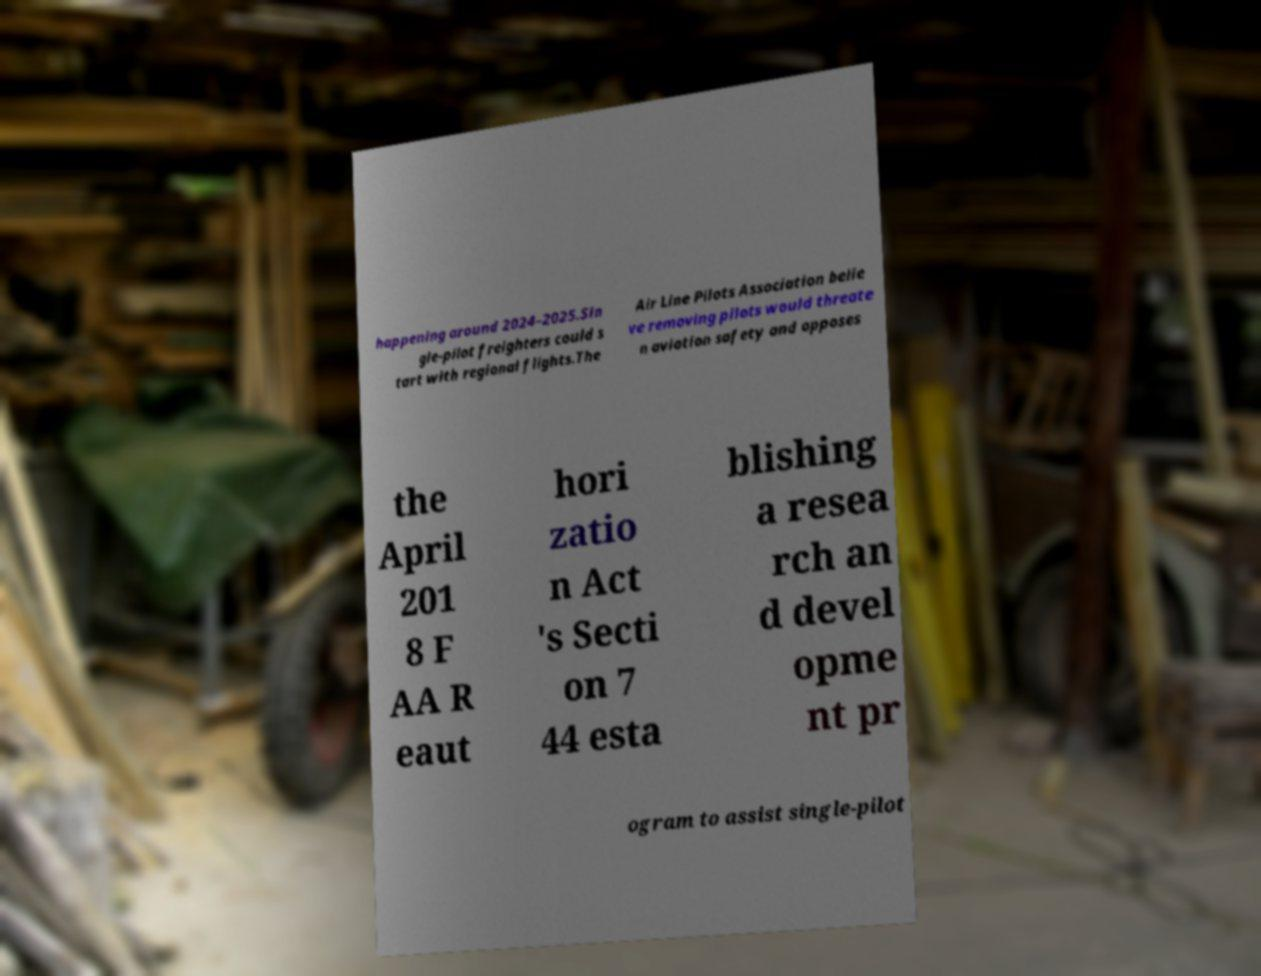Can you read and provide the text displayed in the image?This photo seems to have some interesting text. Can you extract and type it out for me? happening around 2024–2025.Sin gle-pilot freighters could s tart with regional flights.The Air Line Pilots Association belie ve removing pilots would threate n aviation safety and opposes the April 201 8 F AA R eaut hori zatio n Act 's Secti on 7 44 esta blishing a resea rch an d devel opme nt pr ogram to assist single-pilot 